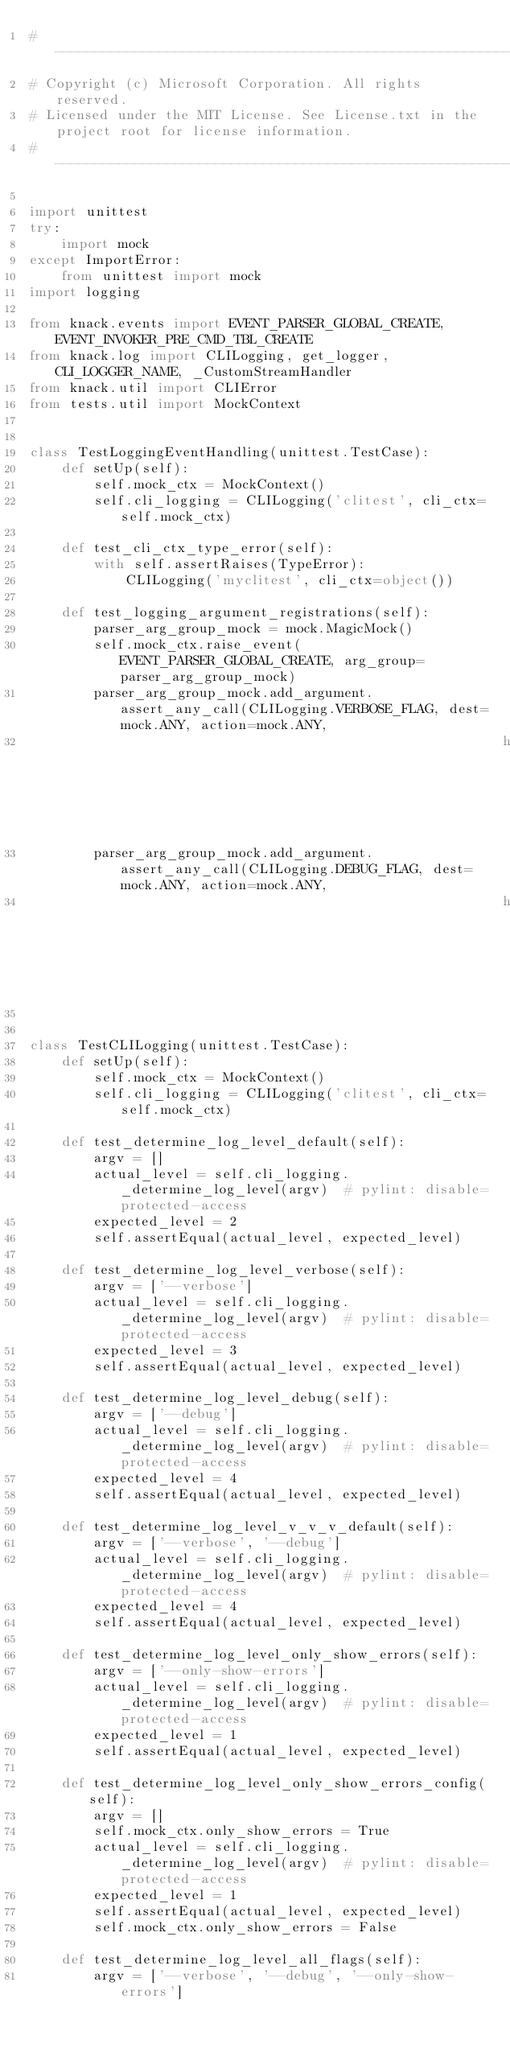<code> <loc_0><loc_0><loc_500><loc_500><_Python_># --------------------------------------------------------------------------------------------
# Copyright (c) Microsoft Corporation. All rights reserved.
# Licensed under the MIT License. See License.txt in the project root for license information.
# --------------------------------------------------------------------------------------------

import unittest
try:
    import mock
except ImportError:
    from unittest import mock
import logging

from knack.events import EVENT_PARSER_GLOBAL_CREATE, EVENT_INVOKER_PRE_CMD_TBL_CREATE
from knack.log import CLILogging, get_logger, CLI_LOGGER_NAME, _CustomStreamHandler
from knack.util import CLIError
from tests.util import MockContext


class TestLoggingEventHandling(unittest.TestCase):
    def setUp(self):
        self.mock_ctx = MockContext()
        self.cli_logging = CLILogging('clitest', cli_ctx=self.mock_ctx)

    def test_cli_ctx_type_error(self):
        with self.assertRaises(TypeError):
            CLILogging('myclitest', cli_ctx=object())

    def test_logging_argument_registrations(self):
        parser_arg_group_mock = mock.MagicMock()
        self.mock_ctx.raise_event(EVENT_PARSER_GLOBAL_CREATE, arg_group=parser_arg_group_mock)
        parser_arg_group_mock.add_argument.assert_any_call(CLILogging.VERBOSE_FLAG, dest=mock.ANY, action=mock.ANY,
                                                           help=mock.ANY)
        parser_arg_group_mock.add_argument.assert_any_call(CLILogging.DEBUG_FLAG, dest=mock.ANY, action=mock.ANY,
                                                           help=mock.ANY)


class TestCLILogging(unittest.TestCase):
    def setUp(self):
        self.mock_ctx = MockContext()
        self.cli_logging = CLILogging('clitest', cli_ctx=self.mock_ctx)

    def test_determine_log_level_default(self):
        argv = []
        actual_level = self.cli_logging._determine_log_level(argv)  # pylint: disable=protected-access
        expected_level = 2
        self.assertEqual(actual_level, expected_level)

    def test_determine_log_level_verbose(self):
        argv = ['--verbose']
        actual_level = self.cli_logging._determine_log_level(argv)  # pylint: disable=protected-access
        expected_level = 3
        self.assertEqual(actual_level, expected_level)

    def test_determine_log_level_debug(self):
        argv = ['--debug']
        actual_level = self.cli_logging._determine_log_level(argv)  # pylint: disable=protected-access
        expected_level = 4
        self.assertEqual(actual_level, expected_level)

    def test_determine_log_level_v_v_v_default(self):
        argv = ['--verbose', '--debug']
        actual_level = self.cli_logging._determine_log_level(argv)  # pylint: disable=protected-access
        expected_level = 4
        self.assertEqual(actual_level, expected_level)

    def test_determine_log_level_only_show_errors(self):
        argv = ['--only-show-errors']
        actual_level = self.cli_logging._determine_log_level(argv)  # pylint: disable=protected-access
        expected_level = 1
        self.assertEqual(actual_level, expected_level)

    def test_determine_log_level_only_show_errors_config(self):
        argv = []
        self.mock_ctx.only_show_errors = True
        actual_level = self.cli_logging._determine_log_level(argv)  # pylint: disable=protected-access
        expected_level = 1
        self.assertEqual(actual_level, expected_level)
        self.mock_ctx.only_show_errors = False

    def test_determine_log_level_all_flags(self):
        argv = ['--verbose', '--debug', '--only-show-errors']</code> 